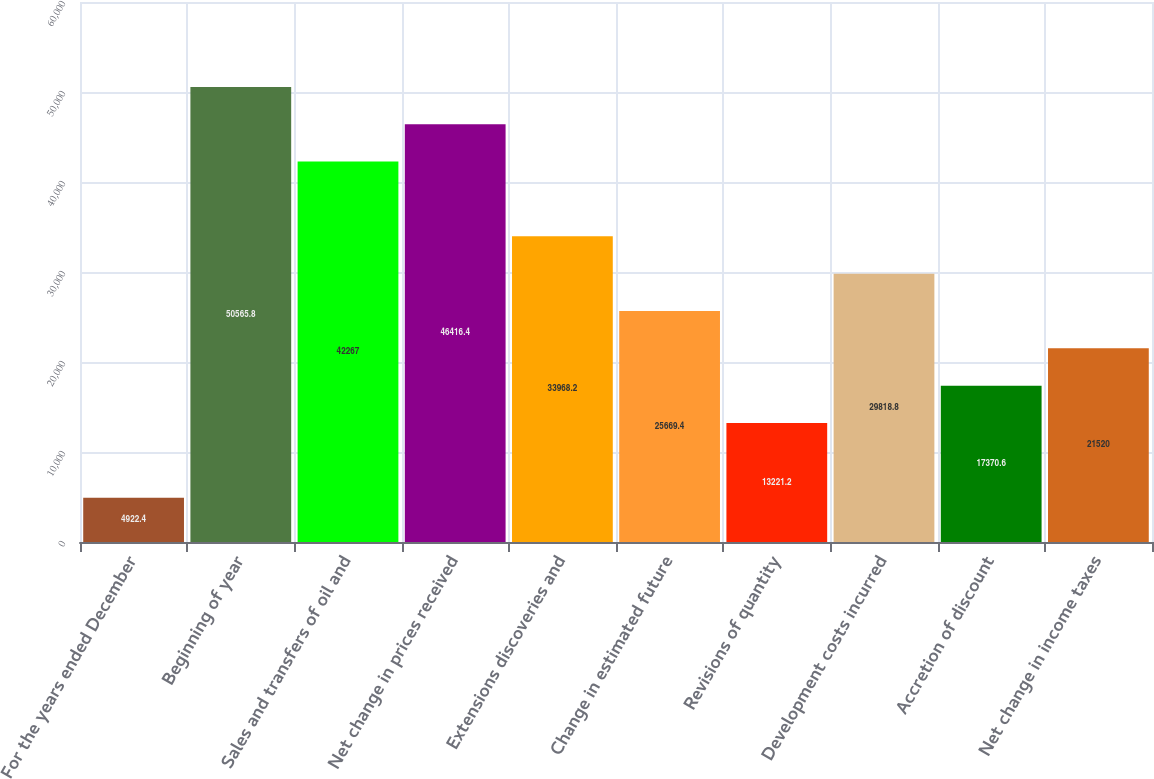Convert chart to OTSL. <chart><loc_0><loc_0><loc_500><loc_500><bar_chart><fcel>For the years ended December<fcel>Beginning of year<fcel>Sales and transfers of oil and<fcel>Net change in prices received<fcel>Extensions discoveries and<fcel>Change in estimated future<fcel>Revisions of quantity<fcel>Development costs incurred<fcel>Accretion of discount<fcel>Net change in income taxes<nl><fcel>4922.4<fcel>50565.8<fcel>42267<fcel>46416.4<fcel>33968.2<fcel>25669.4<fcel>13221.2<fcel>29818.8<fcel>17370.6<fcel>21520<nl></chart> 